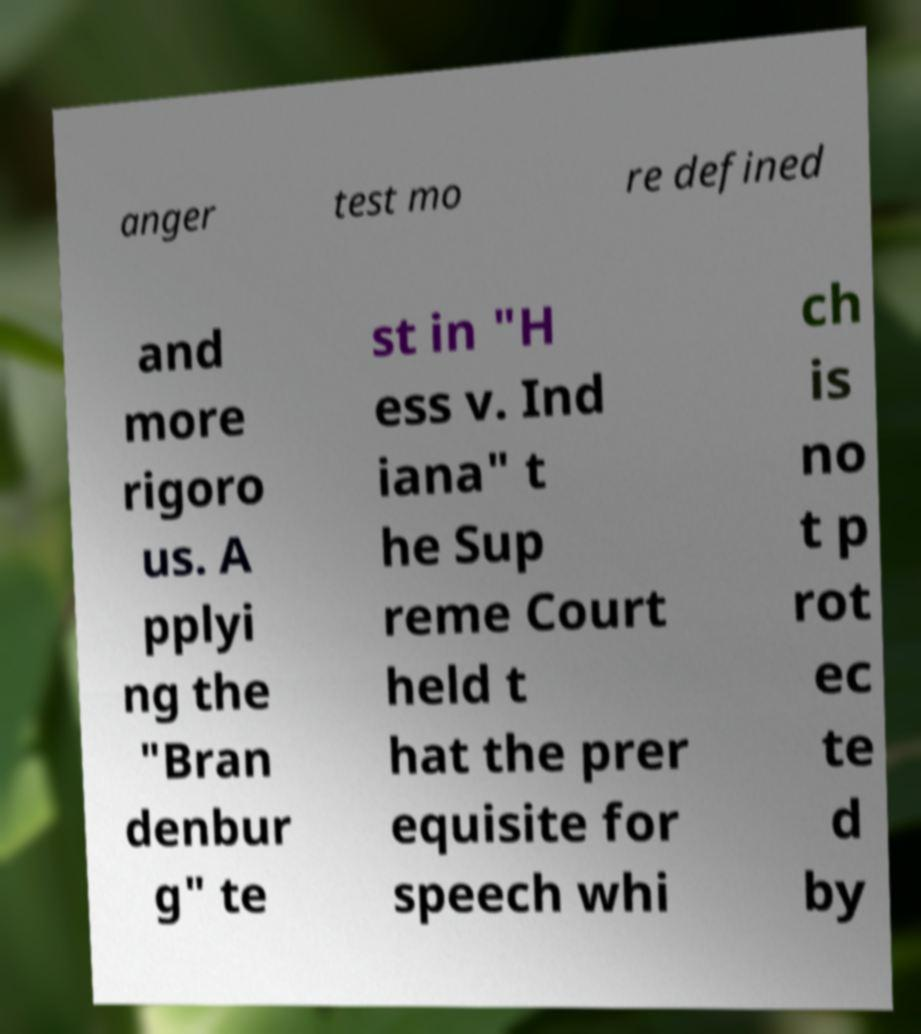Can you read and provide the text displayed in the image?This photo seems to have some interesting text. Can you extract and type it out for me? anger test mo re defined and more rigoro us. A pplyi ng the "Bran denbur g" te st in "H ess v. Ind iana" t he Sup reme Court held t hat the prer equisite for speech whi ch is no t p rot ec te d by 